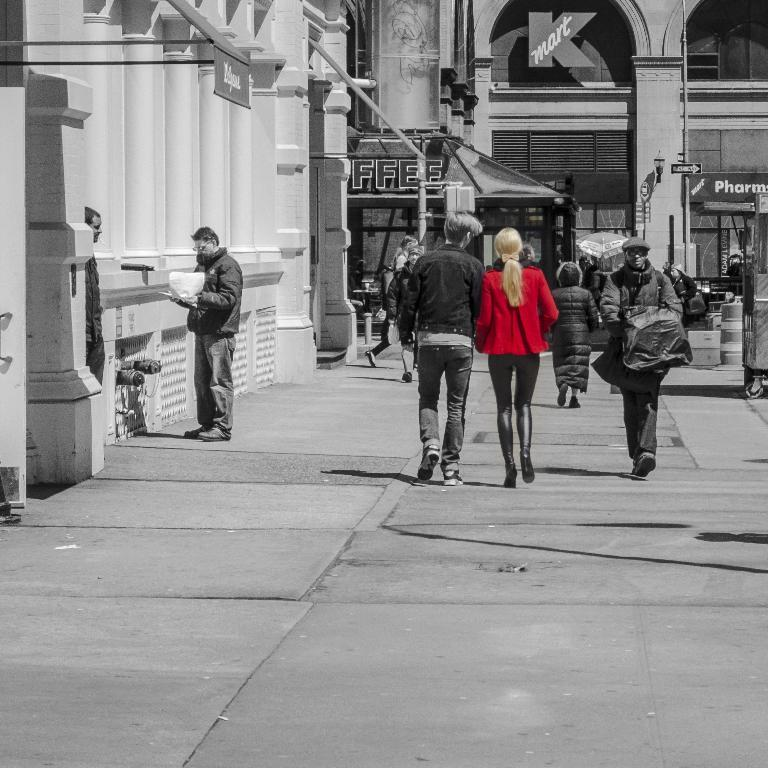What is the man on the left side of the image doing? The man is standing on the left side of the image and holding papers. What can be seen in the background of the image? There are people walking, buildings, and boards in the background. What type of stick can be seen in the man's hand in the image? There is no stick present in the man's hand in the image; he is holding papers. How many birds are visible in the image? There are no birds visible in the image. 